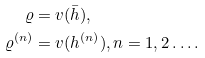Convert formula to latex. <formula><loc_0><loc_0><loc_500><loc_500>\varrho & = v ( \bar { h } ) , \\ \varrho ^ { ( n ) } & = v ( h ^ { ( n ) } ) , n = 1 , 2 \dots .</formula> 